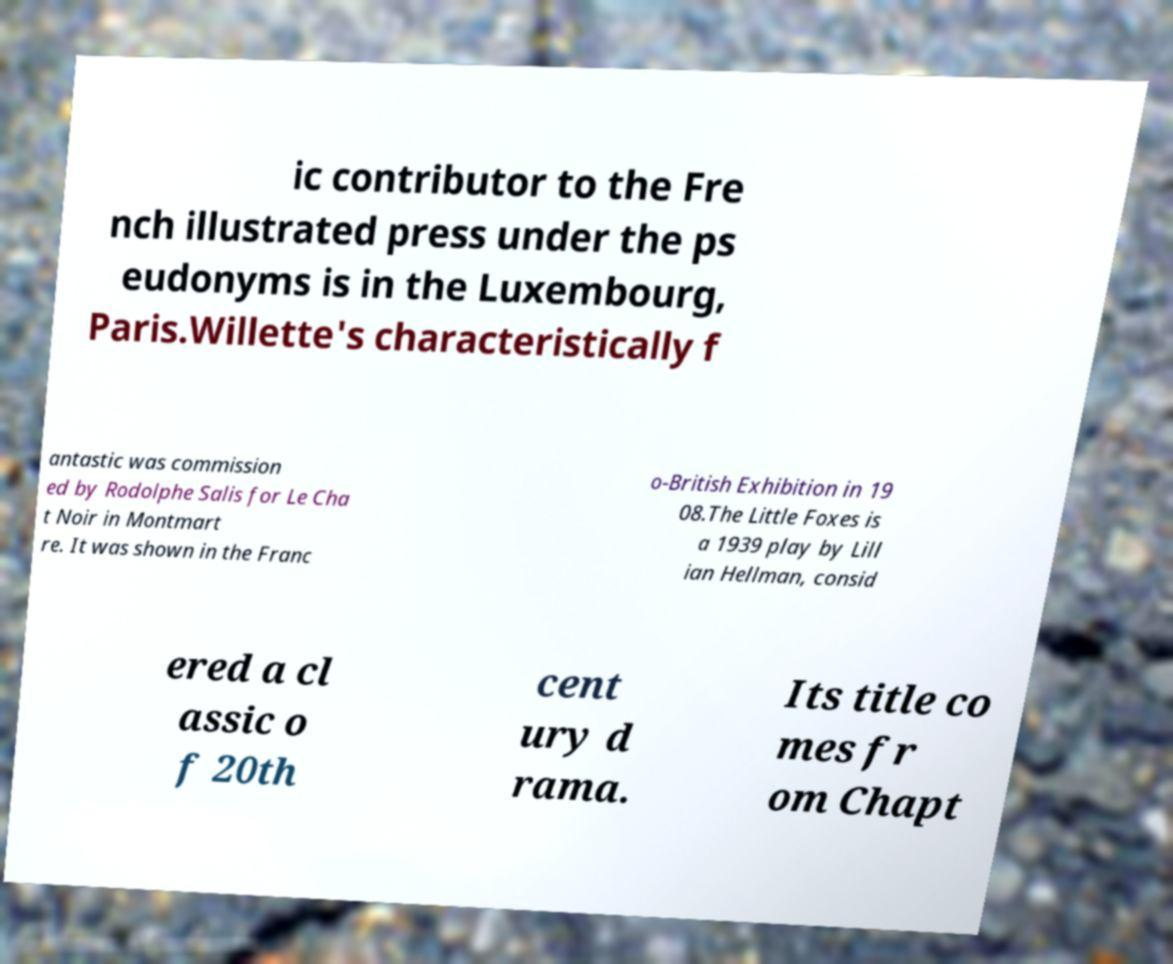Please read and relay the text visible in this image. What does it say? ic contributor to the Fre nch illustrated press under the ps eudonyms is in the Luxembourg, Paris.Willette's characteristically f antastic was commission ed by Rodolphe Salis for Le Cha t Noir in Montmart re. It was shown in the Franc o-British Exhibition in 19 08.The Little Foxes is a 1939 play by Lill ian Hellman, consid ered a cl assic o f 20th cent ury d rama. Its title co mes fr om Chapt 